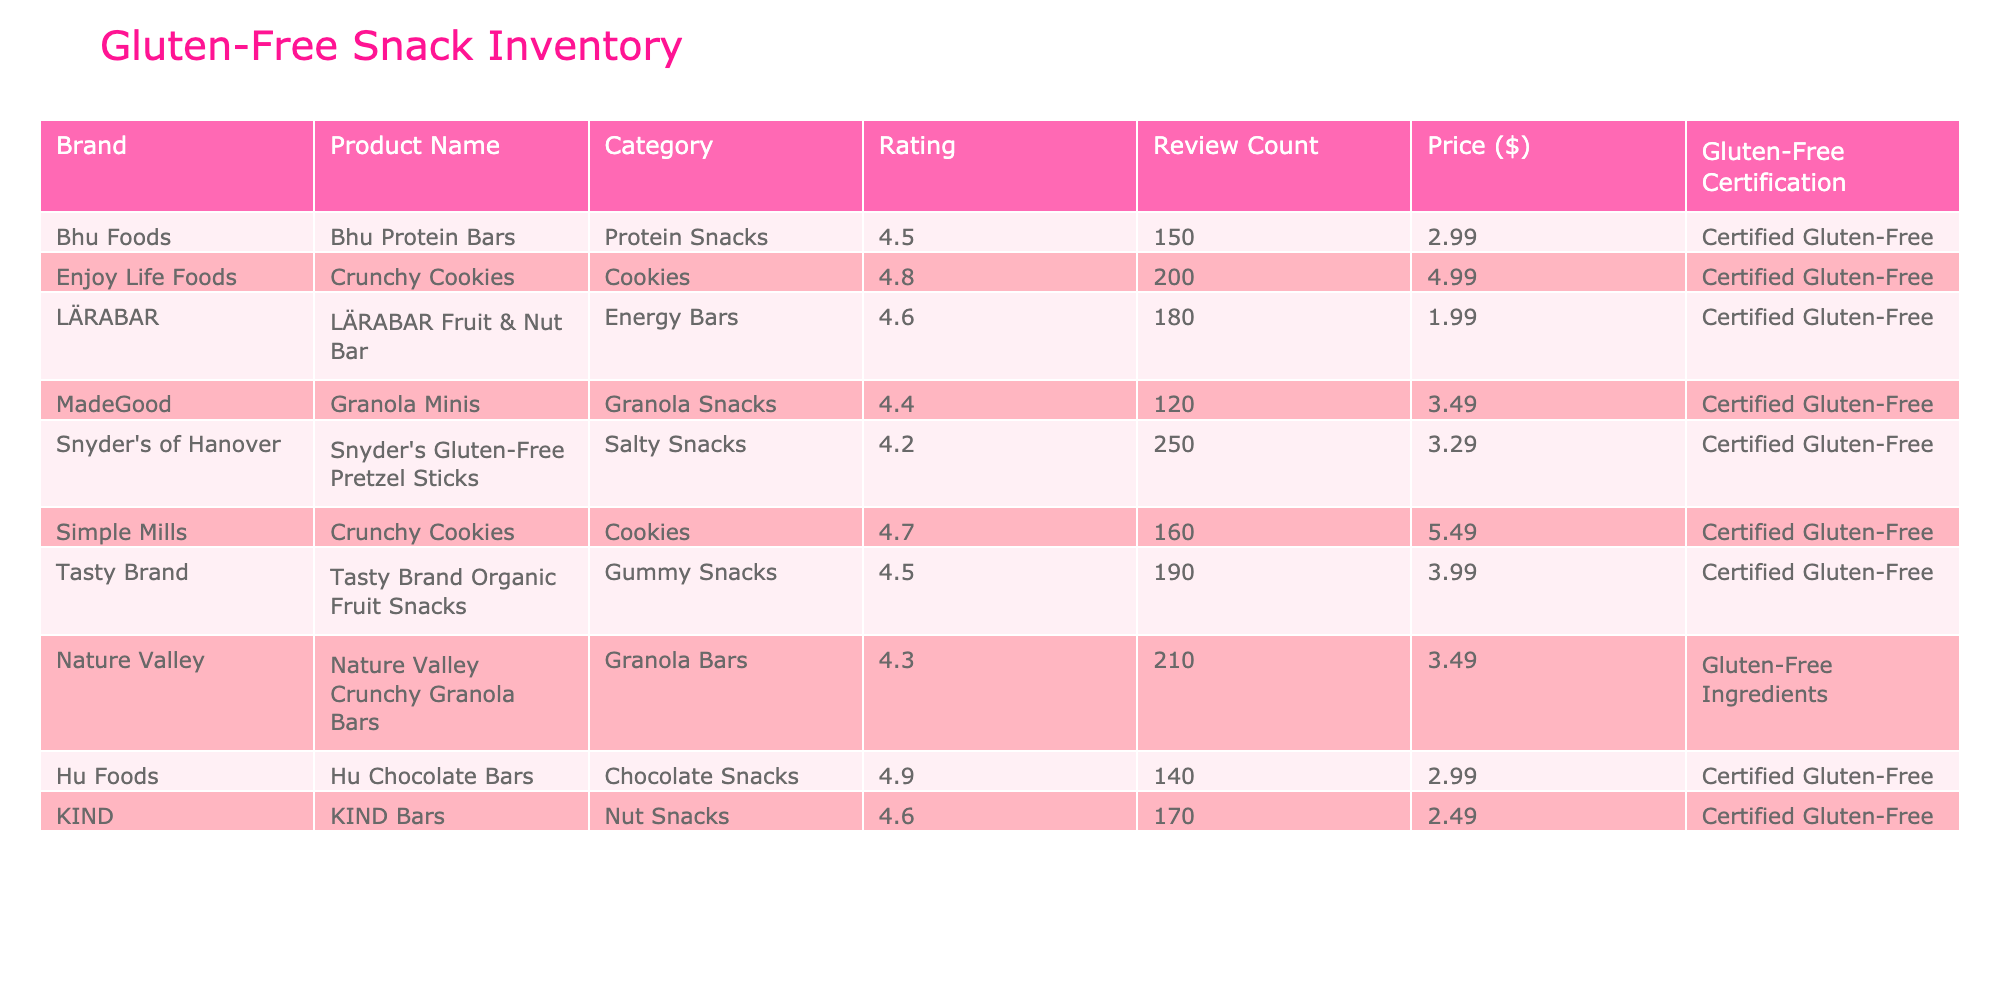What is the highest-rated gluten-free snack? The highest rating in the table is 4.9, which belongs to Hu Chocolate Bars. This is determined by scanning the "Rating" column and identifying the maximum value.
Answer: Hu Chocolate Bars How many reviews does Simple Mills Crunchy Cookies have? From the "Review Count" column, the value for Simple Mills Crunchy Cookies is 160. This is directly retrieved from the respective row in the table.
Answer: 160 What is the average rating of all gluten-free snacks listed? First, we sum the ratings: 4.5 + 4.8 + 4.6 + 4.4 + 4.2 + 4.7 + 4.5 + 4.3 + 4.9 + 4.6 = 46.5. Then, we divide by the total number of snacks (10) to get the average: 46.5 / 10 = 4.65.
Answer: 4.65 Does Nature Valley have a gluten-free certification? Nature Valley is listed as having "Gluten-Free Ingredients," which is not the same as a certified gluten-free status. Thus, the statement is false.
Answer: No Which brand offers the snack with the lowest price? By examining the "Price" column, we find the lowest price is $1.99, which belongs to LÄRABAR. This involves checking each price value and identifying the minimum.
Answer: LÄRABAR What is the total review count for all products under the Cookies category? For the Cookies category, we have 200 (Enjoy Life Foods) and 160 (Simple Mills). We add these values together: 200 + 160 = 360.
Answer: 360 Is the price of KIND Bars greater than $3.00? The price for KIND Bars is listed as $2.49, which is less than $3.00. Hence, the statement is false.
Answer: No What snack has the most reviews? The highest value in "Review Count" is 250, corresponding to Snyder's Gluten-Free Pretzel Sticks. This involves comparing each review count to identify the highest one.
Answer: Snyder's Gluten-Free Pretzel Sticks What is the price difference between the highest and lowest-rated products? The highest-rated product is Hu Chocolate Bars (rating 4.9, price $2.99) and the lowest is Snyder's Gluten-Free Pretzel Sticks (rating 4.2, price $3.29). The price difference is $3.29 - $2.99 = $0.30.
Answer: $0.30 